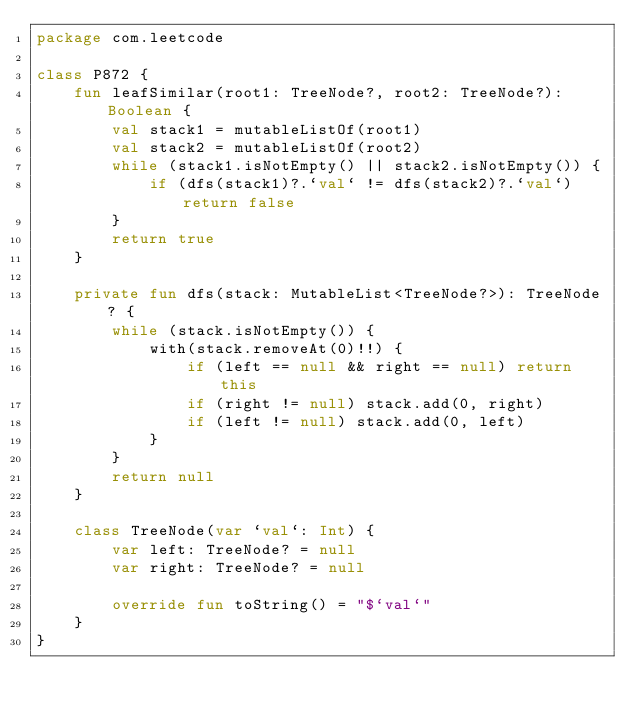Convert code to text. <code><loc_0><loc_0><loc_500><loc_500><_Kotlin_>package com.leetcode

class P872 {
    fun leafSimilar(root1: TreeNode?, root2: TreeNode?): Boolean {
        val stack1 = mutableListOf(root1)
        val stack2 = mutableListOf(root2)
        while (stack1.isNotEmpty() || stack2.isNotEmpty()) {
            if (dfs(stack1)?.`val` != dfs(stack2)?.`val`) return false
        }
        return true
    }

    private fun dfs(stack: MutableList<TreeNode?>): TreeNode? {
        while (stack.isNotEmpty()) {
            with(stack.removeAt(0)!!) {
                if (left == null && right == null) return this
                if (right != null) stack.add(0, right)
                if (left != null) stack.add(0, left)
            }
        }
        return null
    }

    class TreeNode(var `val`: Int) {
        var left: TreeNode? = null
        var right: TreeNode? = null

        override fun toString() = "$`val`"
    }
}
</code> 